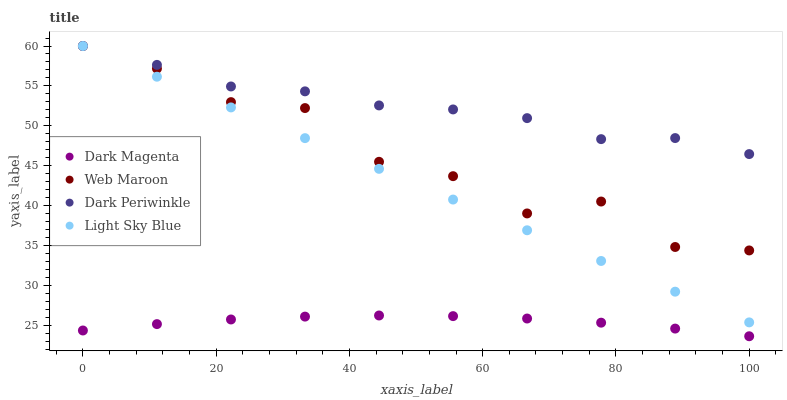Does Dark Magenta have the minimum area under the curve?
Answer yes or no. Yes. Does Dark Periwinkle have the maximum area under the curve?
Answer yes or no. Yes. Does Web Maroon have the minimum area under the curve?
Answer yes or no. No. Does Web Maroon have the maximum area under the curve?
Answer yes or no. No. Is Light Sky Blue the smoothest?
Answer yes or no. Yes. Is Web Maroon the roughest?
Answer yes or no. Yes. Is Dark Magenta the smoothest?
Answer yes or no. No. Is Dark Magenta the roughest?
Answer yes or no. No. Does Dark Magenta have the lowest value?
Answer yes or no. Yes. Does Web Maroon have the lowest value?
Answer yes or no. No. Does Dark Periwinkle have the highest value?
Answer yes or no. Yes. Does Dark Magenta have the highest value?
Answer yes or no. No. Is Dark Magenta less than Light Sky Blue?
Answer yes or no. Yes. Is Web Maroon greater than Dark Magenta?
Answer yes or no. Yes. Does Light Sky Blue intersect Dark Periwinkle?
Answer yes or no. Yes. Is Light Sky Blue less than Dark Periwinkle?
Answer yes or no. No. Is Light Sky Blue greater than Dark Periwinkle?
Answer yes or no. No. Does Dark Magenta intersect Light Sky Blue?
Answer yes or no. No. 